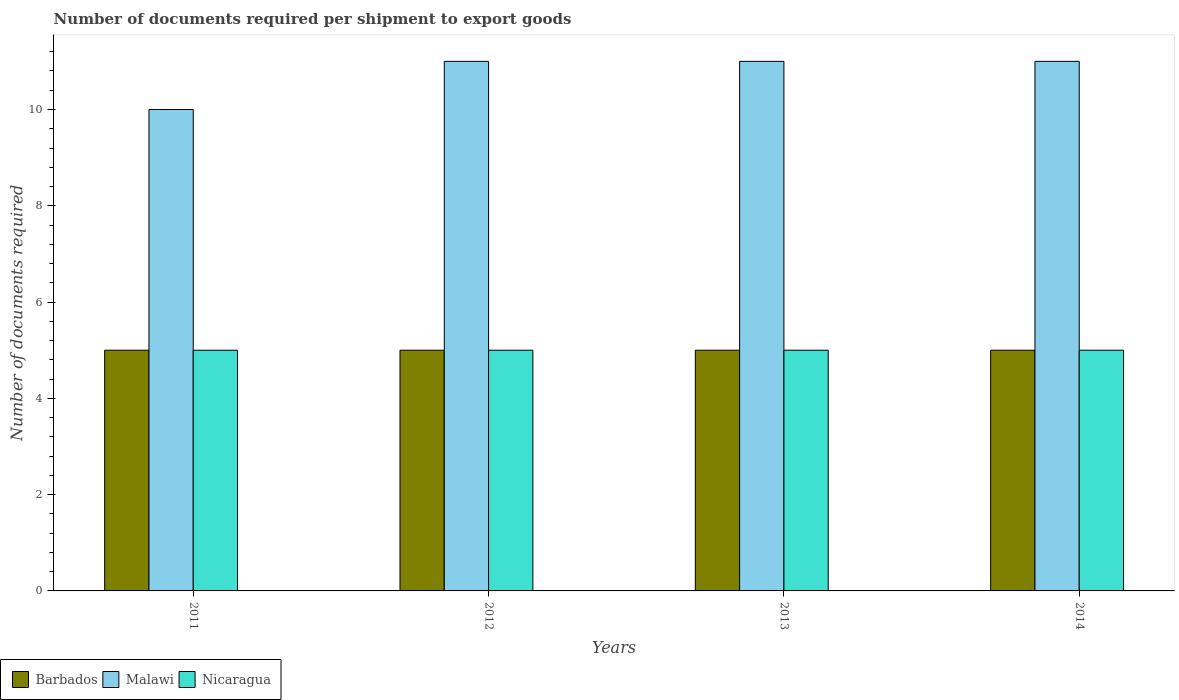How many different coloured bars are there?
Give a very brief answer. 3. How many groups of bars are there?
Ensure brevity in your answer.  4. Are the number of bars per tick equal to the number of legend labels?
Make the answer very short. Yes. What is the number of documents required per shipment to export goods in Malawi in 2014?
Offer a terse response. 11. Across all years, what is the maximum number of documents required per shipment to export goods in Nicaragua?
Your answer should be very brief. 5. In which year was the number of documents required per shipment to export goods in Nicaragua minimum?
Ensure brevity in your answer.  2011. What is the difference between the number of documents required per shipment to export goods in Malawi in 2011 and that in 2014?
Your response must be concise. -1. What is the difference between the number of documents required per shipment to export goods in Nicaragua in 2011 and the number of documents required per shipment to export goods in Barbados in 2013?
Ensure brevity in your answer.  0. What is the average number of documents required per shipment to export goods in Malawi per year?
Offer a very short reply. 10.75. In the year 2011, what is the difference between the number of documents required per shipment to export goods in Barbados and number of documents required per shipment to export goods in Malawi?
Provide a succinct answer. -5. In how many years, is the number of documents required per shipment to export goods in Barbados greater than 5.2?
Give a very brief answer. 0. What is the ratio of the number of documents required per shipment to export goods in Nicaragua in 2012 to that in 2013?
Offer a very short reply. 1. Is the number of documents required per shipment to export goods in Nicaragua in 2012 less than that in 2013?
Keep it short and to the point. No. Is the difference between the number of documents required per shipment to export goods in Barbados in 2011 and 2012 greater than the difference between the number of documents required per shipment to export goods in Malawi in 2011 and 2012?
Provide a succinct answer. Yes. What is the difference between the highest and the lowest number of documents required per shipment to export goods in Malawi?
Your response must be concise. 1. In how many years, is the number of documents required per shipment to export goods in Malawi greater than the average number of documents required per shipment to export goods in Malawi taken over all years?
Ensure brevity in your answer.  3. Is the sum of the number of documents required per shipment to export goods in Malawi in 2011 and 2013 greater than the maximum number of documents required per shipment to export goods in Barbados across all years?
Your response must be concise. Yes. What does the 2nd bar from the left in 2014 represents?
Offer a very short reply. Malawi. What does the 3rd bar from the right in 2011 represents?
Provide a succinct answer. Barbados. Is it the case that in every year, the sum of the number of documents required per shipment to export goods in Malawi and number of documents required per shipment to export goods in Nicaragua is greater than the number of documents required per shipment to export goods in Barbados?
Provide a succinct answer. Yes. How many bars are there?
Make the answer very short. 12. How many years are there in the graph?
Give a very brief answer. 4. What is the difference between two consecutive major ticks on the Y-axis?
Make the answer very short. 2. Are the values on the major ticks of Y-axis written in scientific E-notation?
Provide a succinct answer. No. How many legend labels are there?
Offer a very short reply. 3. What is the title of the graph?
Keep it short and to the point. Number of documents required per shipment to export goods. What is the label or title of the X-axis?
Your response must be concise. Years. What is the label or title of the Y-axis?
Make the answer very short. Number of documents required. What is the Number of documents required in Barbados in 2011?
Give a very brief answer. 5. What is the Number of documents required in Nicaragua in 2011?
Offer a terse response. 5. What is the Number of documents required of Barbados in 2012?
Ensure brevity in your answer.  5. What is the Number of documents required of Malawi in 2012?
Make the answer very short. 11. What is the Number of documents required in Nicaragua in 2012?
Make the answer very short. 5. What is the Number of documents required in Barbados in 2014?
Make the answer very short. 5. Across all years, what is the maximum Number of documents required in Barbados?
Provide a short and direct response. 5. Across all years, what is the maximum Number of documents required in Malawi?
Make the answer very short. 11. Across all years, what is the minimum Number of documents required of Barbados?
Offer a very short reply. 5. Across all years, what is the minimum Number of documents required in Malawi?
Your response must be concise. 10. What is the total Number of documents required in Barbados in the graph?
Ensure brevity in your answer.  20. What is the total Number of documents required in Malawi in the graph?
Make the answer very short. 43. What is the difference between the Number of documents required in Barbados in 2011 and that in 2012?
Offer a very short reply. 0. What is the difference between the Number of documents required of Malawi in 2011 and that in 2013?
Your response must be concise. -1. What is the difference between the Number of documents required in Malawi in 2011 and that in 2014?
Keep it short and to the point. -1. What is the difference between the Number of documents required of Nicaragua in 2011 and that in 2014?
Your answer should be very brief. 0. What is the difference between the Number of documents required of Barbados in 2012 and that in 2013?
Offer a very short reply. 0. What is the difference between the Number of documents required of Nicaragua in 2012 and that in 2013?
Your answer should be compact. 0. What is the difference between the Number of documents required in Barbados in 2012 and that in 2014?
Offer a terse response. 0. What is the difference between the Number of documents required of Malawi in 2012 and that in 2014?
Give a very brief answer. 0. What is the difference between the Number of documents required in Nicaragua in 2012 and that in 2014?
Give a very brief answer. 0. What is the difference between the Number of documents required of Barbados in 2011 and the Number of documents required of Malawi in 2012?
Make the answer very short. -6. What is the difference between the Number of documents required of Malawi in 2011 and the Number of documents required of Nicaragua in 2012?
Your response must be concise. 5. What is the difference between the Number of documents required of Barbados in 2011 and the Number of documents required of Malawi in 2013?
Provide a succinct answer. -6. What is the difference between the Number of documents required in Barbados in 2011 and the Number of documents required in Nicaragua in 2013?
Offer a very short reply. 0. What is the difference between the Number of documents required of Barbados in 2011 and the Number of documents required of Malawi in 2014?
Offer a very short reply. -6. What is the difference between the Number of documents required of Barbados in 2011 and the Number of documents required of Nicaragua in 2014?
Offer a very short reply. 0. What is the difference between the Number of documents required in Malawi in 2011 and the Number of documents required in Nicaragua in 2014?
Offer a very short reply. 5. What is the difference between the Number of documents required of Barbados in 2012 and the Number of documents required of Malawi in 2013?
Provide a short and direct response. -6. What is the difference between the Number of documents required of Barbados in 2012 and the Number of documents required of Nicaragua in 2013?
Provide a succinct answer. 0. What is the difference between the Number of documents required of Barbados in 2012 and the Number of documents required of Nicaragua in 2014?
Ensure brevity in your answer.  0. What is the difference between the Number of documents required in Barbados in 2013 and the Number of documents required in Malawi in 2014?
Offer a terse response. -6. What is the average Number of documents required in Malawi per year?
Provide a succinct answer. 10.75. What is the average Number of documents required in Nicaragua per year?
Offer a very short reply. 5. In the year 2011, what is the difference between the Number of documents required in Barbados and Number of documents required in Nicaragua?
Provide a short and direct response. 0. In the year 2013, what is the difference between the Number of documents required of Barbados and Number of documents required of Malawi?
Your response must be concise. -6. In the year 2014, what is the difference between the Number of documents required in Barbados and Number of documents required in Malawi?
Your answer should be compact. -6. In the year 2014, what is the difference between the Number of documents required of Barbados and Number of documents required of Nicaragua?
Your answer should be very brief. 0. In the year 2014, what is the difference between the Number of documents required in Malawi and Number of documents required in Nicaragua?
Provide a short and direct response. 6. What is the ratio of the Number of documents required of Barbados in 2011 to that in 2013?
Make the answer very short. 1. What is the ratio of the Number of documents required in Malawi in 2011 to that in 2013?
Your answer should be compact. 0.91. What is the ratio of the Number of documents required of Nicaragua in 2011 to that in 2013?
Your answer should be very brief. 1. What is the ratio of the Number of documents required in Barbados in 2012 to that in 2013?
Give a very brief answer. 1. What is the ratio of the Number of documents required of Barbados in 2012 to that in 2014?
Your answer should be compact. 1. What is the ratio of the Number of documents required of Nicaragua in 2012 to that in 2014?
Provide a succinct answer. 1. What is the ratio of the Number of documents required in Malawi in 2013 to that in 2014?
Offer a very short reply. 1. What is the difference between the highest and the second highest Number of documents required in Nicaragua?
Keep it short and to the point. 0. What is the difference between the highest and the lowest Number of documents required in Barbados?
Give a very brief answer. 0. What is the difference between the highest and the lowest Number of documents required in Malawi?
Keep it short and to the point. 1. 